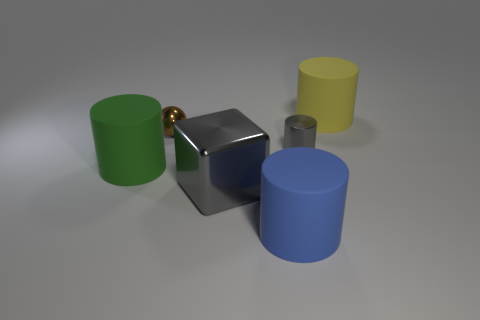Add 1 large gray shiny things. How many objects exist? 7 Subtract all spheres. How many objects are left? 5 Add 2 big blue objects. How many big blue objects exist? 3 Subtract 0 yellow cubes. How many objects are left? 6 Subtract all big blocks. Subtract all brown shiny objects. How many objects are left? 4 Add 6 blue things. How many blue things are left? 7 